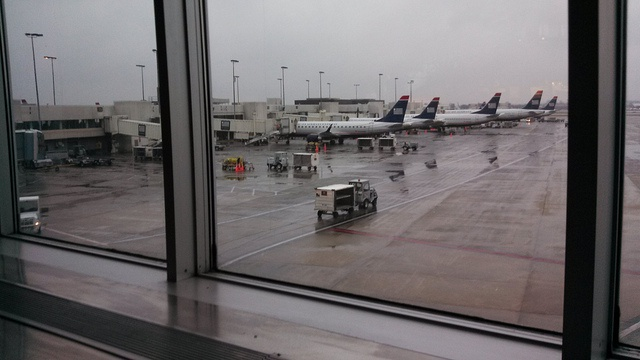Describe the objects in this image and their specific colors. I can see airplane in black, gray, darkgray, and lightgray tones, truck in black, gray, darkgray, and lightgray tones, airplane in black, darkgray, gray, and lightgray tones, truck in black, gray, and darkgray tones, and airplane in black, gray, darkgray, and lightgray tones in this image. 